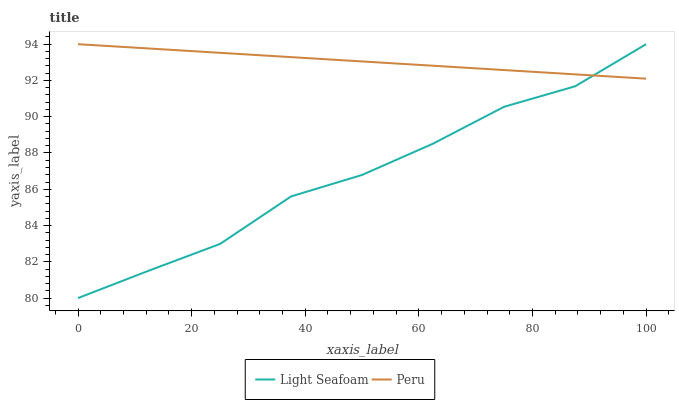Does Light Seafoam have the minimum area under the curve?
Answer yes or no. Yes. Does Peru have the maximum area under the curve?
Answer yes or no. Yes. Does Peru have the minimum area under the curve?
Answer yes or no. No. Is Peru the smoothest?
Answer yes or no. Yes. Is Light Seafoam the roughest?
Answer yes or no. Yes. Is Peru the roughest?
Answer yes or no. No. Does Light Seafoam have the lowest value?
Answer yes or no. Yes. Does Peru have the lowest value?
Answer yes or no. No. Does Peru have the highest value?
Answer yes or no. Yes. Does Light Seafoam intersect Peru?
Answer yes or no. Yes. Is Light Seafoam less than Peru?
Answer yes or no. No. Is Light Seafoam greater than Peru?
Answer yes or no. No. 